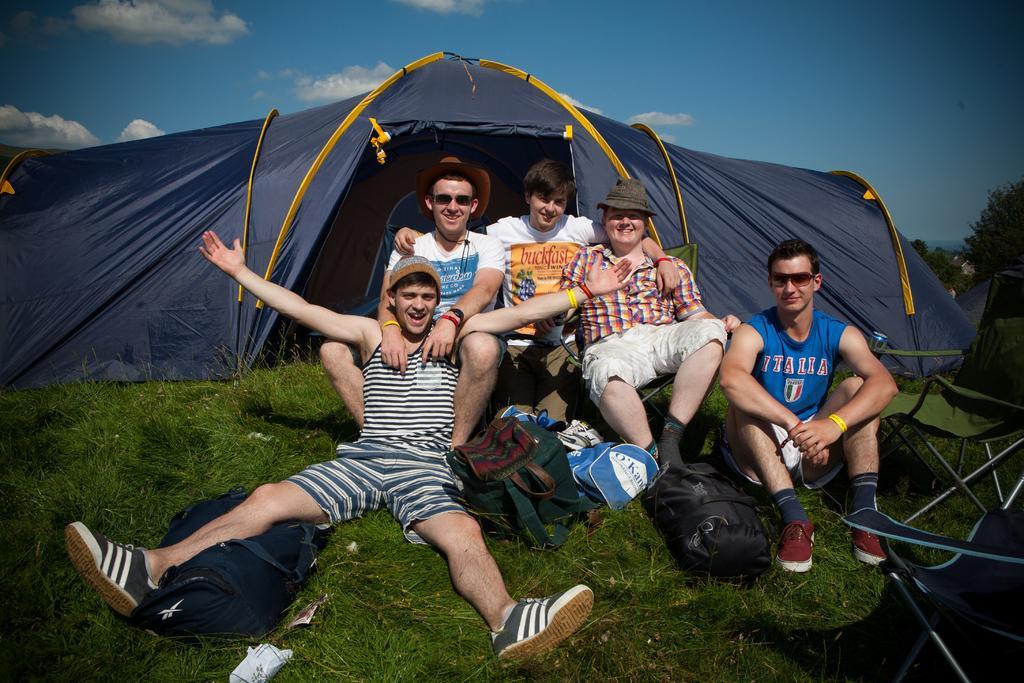Can you describe this image briefly? In this image there are group of persons sitting on grass and smiling. There are bags on the grass. In the background there is a tent which is black in colour, and the sky is cloudy. On the right side there are trees and there are chairs. 